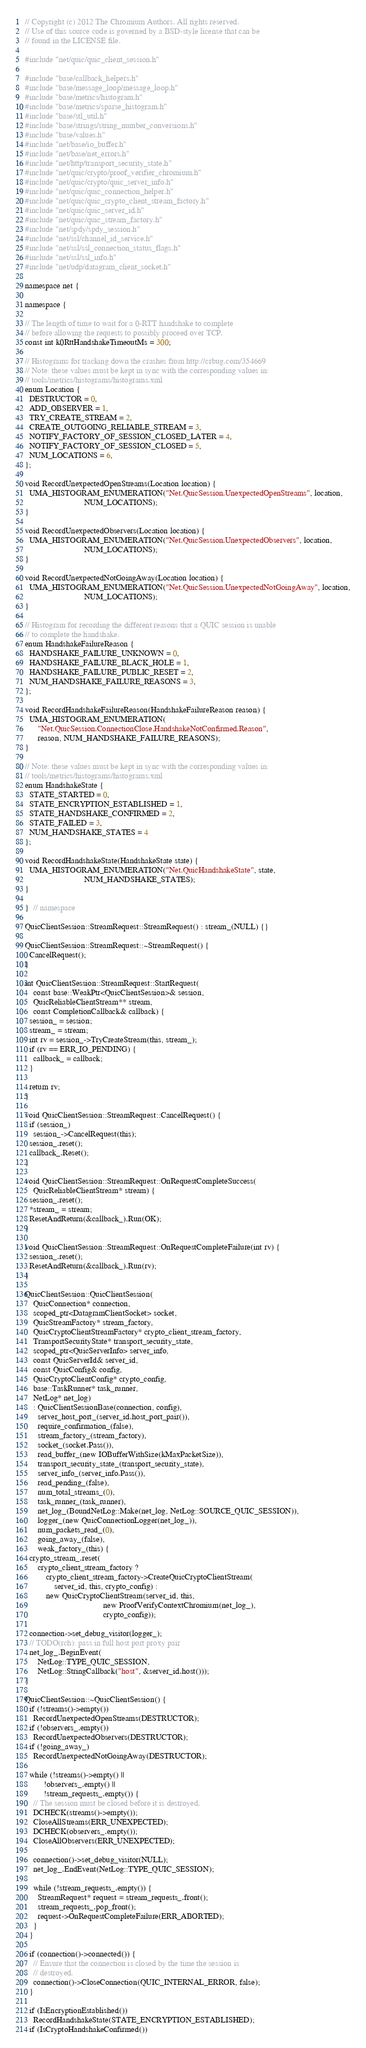Convert code to text. <code><loc_0><loc_0><loc_500><loc_500><_C++_>// Copyright (c) 2012 The Chromium Authors. All rights reserved.
// Use of this source code is governed by a BSD-style license that can be
// found in the LICENSE file.

#include "net/quic/quic_client_session.h"

#include "base/callback_helpers.h"
#include "base/message_loop/message_loop.h"
#include "base/metrics/histogram.h"
#include "base/metrics/sparse_histogram.h"
#include "base/stl_util.h"
#include "base/strings/string_number_conversions.h"
#include "base/values.h"
#include "net/base/io_buffer.h"
#include "net/base/net_errors.h"
#include "net/http/transport_security_state.h"
#include "net/quic/crypto/proof_verifier_chromium.h"
#include "net/quic/crypto/quic_server_info.h"
#include "net/quic/quic_connection_helper.h"
#include "net/quic/quic_crypto_client_stream_factory.h"
#include "net/quic/quic_server_id.h"
#include "net/quic/quic_stream_factory.h"
#include "net/spdy/spdy_session.h"
#include "net/ssl/channel_id_service.h"
#include "net/ssl/ssl_connection_status_flags.h"
#include "net/ssl/ssl_info.h"
#include "net/udp/datagram_client_socket.h"

namespace net {

namespace {

// The length of time to wait for a 0-RTT handshake to complete
// before allowing the requests to possibly proceed over TCP.
const int k0RttHandshakeTimeoutMs = 300;

// Histograms for tracking down the crashes from http://crbug.com/354669
// Note: these values must be kept in sync with the corresponding values in:
// tools/metrics/histograms/histograms.xml
enum Location {
  DESTRUCTOR = 0,
  ADD_OBSERVER = 1,
  TRY_CREATE_STREAM = 2,
  CREATE_OUTGOING_RELIABLE_STREAM = 3,
  NOTIFY_FACTORY_OF_SESSION_CLOSED_LATER = 4,
  NOTIFY_FACTORY_OF_SESSION_CLOSED = 5,
  NUM_LOCATIONS = 6,
};

void RecordUnexpectedOpenStreams(Location location) {
  UMA_HISTOGRAM_ENUMERATION("Net.QuicSession.UnexpectedOpenStreams", location,
                            NUM_LOCATIONS);
}

void RecordUnexpectedObservers(Location location) {
  UMA_HISTOGRAM_ENUMERATION("Net.QuicSession.UnexpectedObservers", location,
                            NUM_LOCATIONS);
}

void RecordUnexpectedNotGoingAway(Location location) {
  UMA_HISTOGRAM_ENUMERATION("Net.QuicSession.UnexpectedNotGoingAway", location,
                            NUM_LOCATIONS);
}

// Histogram for recording the different reasons that a QUIC session is unable
// to complete the handshake.
enum HandshakeFailureReason {
  HANDSHAKE_FAILURE_UNKNOWN = 0,
  HANDSHAKE_FAILURE_BLACK_HOLE = 1,
  HANDSHAKE_FAILURE_PUBLIC_RESET = 2,
  NUM_HANDSHAKE_FAILURE_REASONS = 3,
};

void RecordHandshakeFailureReason(HandshakeFailureReason reason) {
  UMA_HISTOGRAM_ENUMERATION(
      "Net.QuicSession.ConnectionClose.HandshakeNotConfirmed.Reason",
      reason, NUM_HANDSHAKE_FAILURE_REASONS);
}

// Note: these values must be kept in sync with the corresponding values in:
// tools/metrics/histograms/histograms.xml
enum HandshakeState {
  STATE_STARTED = 0,
  STATE_ENCRYPTION_ESTABLISHED = 1,
  STATE_HANDSHAKE_CONFIRMED = 2,
  STATE_FAILED = 3,
  NUM_HANDSHAKE_STATES = 4
};

void RecordHandshakeState(HandshakeState state) {
  UMA_HISTOGRAM_ENUMERATION("Net.QuicHandshakeState", state,
                            NUM_HANDSHAKE_STATES);
}

}  // namespace

QuicClientSession::StreamRequest::StreamRequest() : stream_(NULL) {}

QuicClientSession::StreamRequest::~StreamRequest() {
  CancelRequest();
}

int QuicClientSession::StreamRequest::StartRequest(
    const base::WeakPtr<QuicClientSession>& session,
    QuicReliableClientStream** stream,
    const CompletionCallback& callback) {
  session_ = session;
  stream_ = stream;
  int rv = session_->TryCreateStream(this, stream_);
  if (rv == ERR_IO_PENDING) {
    callback_ = callback;
  }

  return rv;
}

void QuicClientSession::StreamRequest::CancelRequest() {
  if (session_)
    session_->CancelRequest(this);
  session_.reset();
  callback_.Reset();
}

void QuicClientSession::StreamRequest::OnRequestCompleteSuccess(
    QuicReliableClientStream* stream) {
  session_.reset();
  *stream_ = stream;
  ResetAndReturn(&callback_).Run(OK);
}

void QuicClientSession::StreamRequest::OnRequestCompleteFailure(int rv) {
  session_.reset();
  ResetAndReturn(&callback_).Run(rv);
}

QuicClientSession::QuicClientSession(
    QuicConnection* connection,
    scoped_ptr<DatagramClientSocket> socket,
    QuicStreamFactory* stream_factory,
    QuicCryptoClientStreamFactory* crypto_client_stream_factory,
    TransportSecurityState* transport_security_state,
    scoped_ptr<QuicServerInfo> server_info,
    const QuicServerId& server_id,
    const QuicConfig& config,
    QuicCryptoClientConfig* crypto_config,
    base::TaskRunner* task_runner,
    NetLog* net_log)
    : QuicClientSessionBase(connection, config),
      server_host_port_(server_id.host_port_pair()),
      require_confirmation_(false),
      stream_factory_(stream_factory),
      socket_(socket.Pass()),
      read_buffer_(new IOBufferWithSize(kMaxPacketSize)),
      transport_security_state_(transport_security_state),
      server_info_(server_info.Pass()),
      read_pending_(false),
      num_total_streams_(0),
      task_runner_(task_runner),
      net_log_(BoundNetLog::Make(net_log, NetLog::SOURCE_QUIC_SESSION)),
      logger_(new QuicConnectionLogger(net_log_)),
      num_packets_read_(0),
      going_away_(false),
      weak_factory_(this) {
  crypto_stream_.reset(
      crypto_client_stream_factory ?
          crypto_client_stream_factory->CreateQuicCryptoClientStream(
              server_id, this, crypto_config) :
          new QuicCryptoClientStream(server_id, this,
                                     new ProofVerifyContextChromium(net_log_),
                                     crypto_config));

  connection->set_debug_visitor(logger_);
  // TODO(rch): pass in full host port proxy pair
  net_log_.BeginEvent(
      NetLog::TYPE_QUIC_SESSION,
      NetLog::StringCallback("host", &server_id.host()));
}

QuicClientSession::~QuicClientSession() {
  if (!streams()->empty())
    RecordUnexpectedOpenStreams(DESTRUCTOR);
  if (!observers_.empty())
    RecordUnexpectedObservers(DESTRUCTOR);
  if (!going_away_)
    RecordUnexpectedNotGoingAway(DESTRUCTOR);

  while (!streams()->empty() ||
         !observers_.empty() ||
         !stream_requests_.empty()) {
    // The session must be closed before it is destroyed.
    DCHECK(streams()->empty());
    CloseAllStreams(ERR_UNEXPECTED);
    DCHECK(observers_.empty());
    CloseAllObservers(ERR_UNEXPECTED);

    connection()->set_debug_visitor(NULL);
    net_log_.EndEvent(NetLog::TYPE_QUIC_SESSION);

    while (!stream_requests_.empty()) {
      StreamRequest* request = stream_requests_.front();
      stream_requests_.pop_front();
      request->OnRequestCompleteFailure(ERR_ABORTED);
    }
  }

  if (connection()->connected()) {
    // Ensure that the connection is closed by the time the session is
    // destroyed.
    connection()->CloseConnection(QUIC_INTERNAL_ERROR, false);
  }

  if (IsEncryptionEstablished())
    RecordHandshakeState(STATE_ENCRYPTION_ESTABLISHED);
  if (IsCryptoHandshakeConfirmed())</code> 